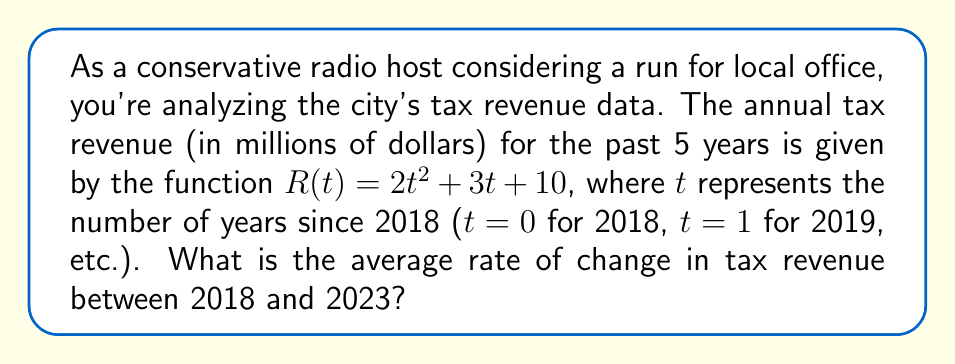Solve this math problem. To find the average rate of change in tax revenue between 2018 and 2023, we need to calculate the slope of the line connecting the points (0, R(0)) and (5, R(5)). This can be done using the following steps:

1. Calculate R(0) for 2018:
   $R(0) = 2(0)^2 + 3(0) + 10 = 10$ million dollars

2. Calculate R(5) for 2023:
   $R(5) = 2(5)^2 + 3(5) + 10 = 2(25) + 15 + 10 = 75$ million dollars

3. Use the average rate of change formula:
   $$\text{Average rate of change} = \frac{R(5) - R(0)}{5 - 0} = \frac{75 - 10}{5} = \frac{65}{5} = 13$$

The average rate of change represents the average increase in tax revenue per year over the 5-year period.
Answer: The average rate of change in tax revenue between 2018 and 2023 is $13$ million dollars per year. 